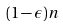Convert formula to latex. <formula><loc_0><loc_0><loc_500><loc_500>( 1 - \epsilon ) n</formula> 